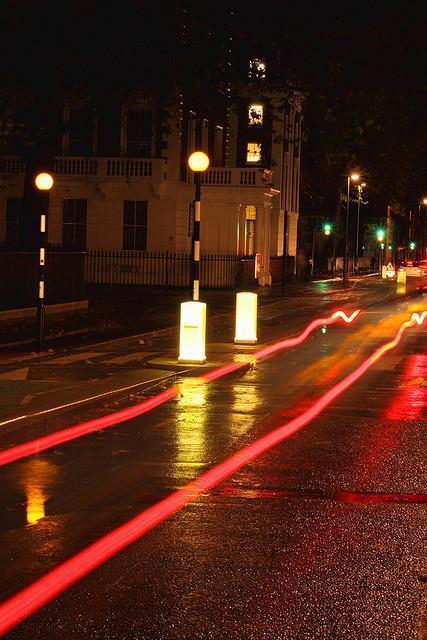How many people not on bikes?
Give a very brief answer. 0. 